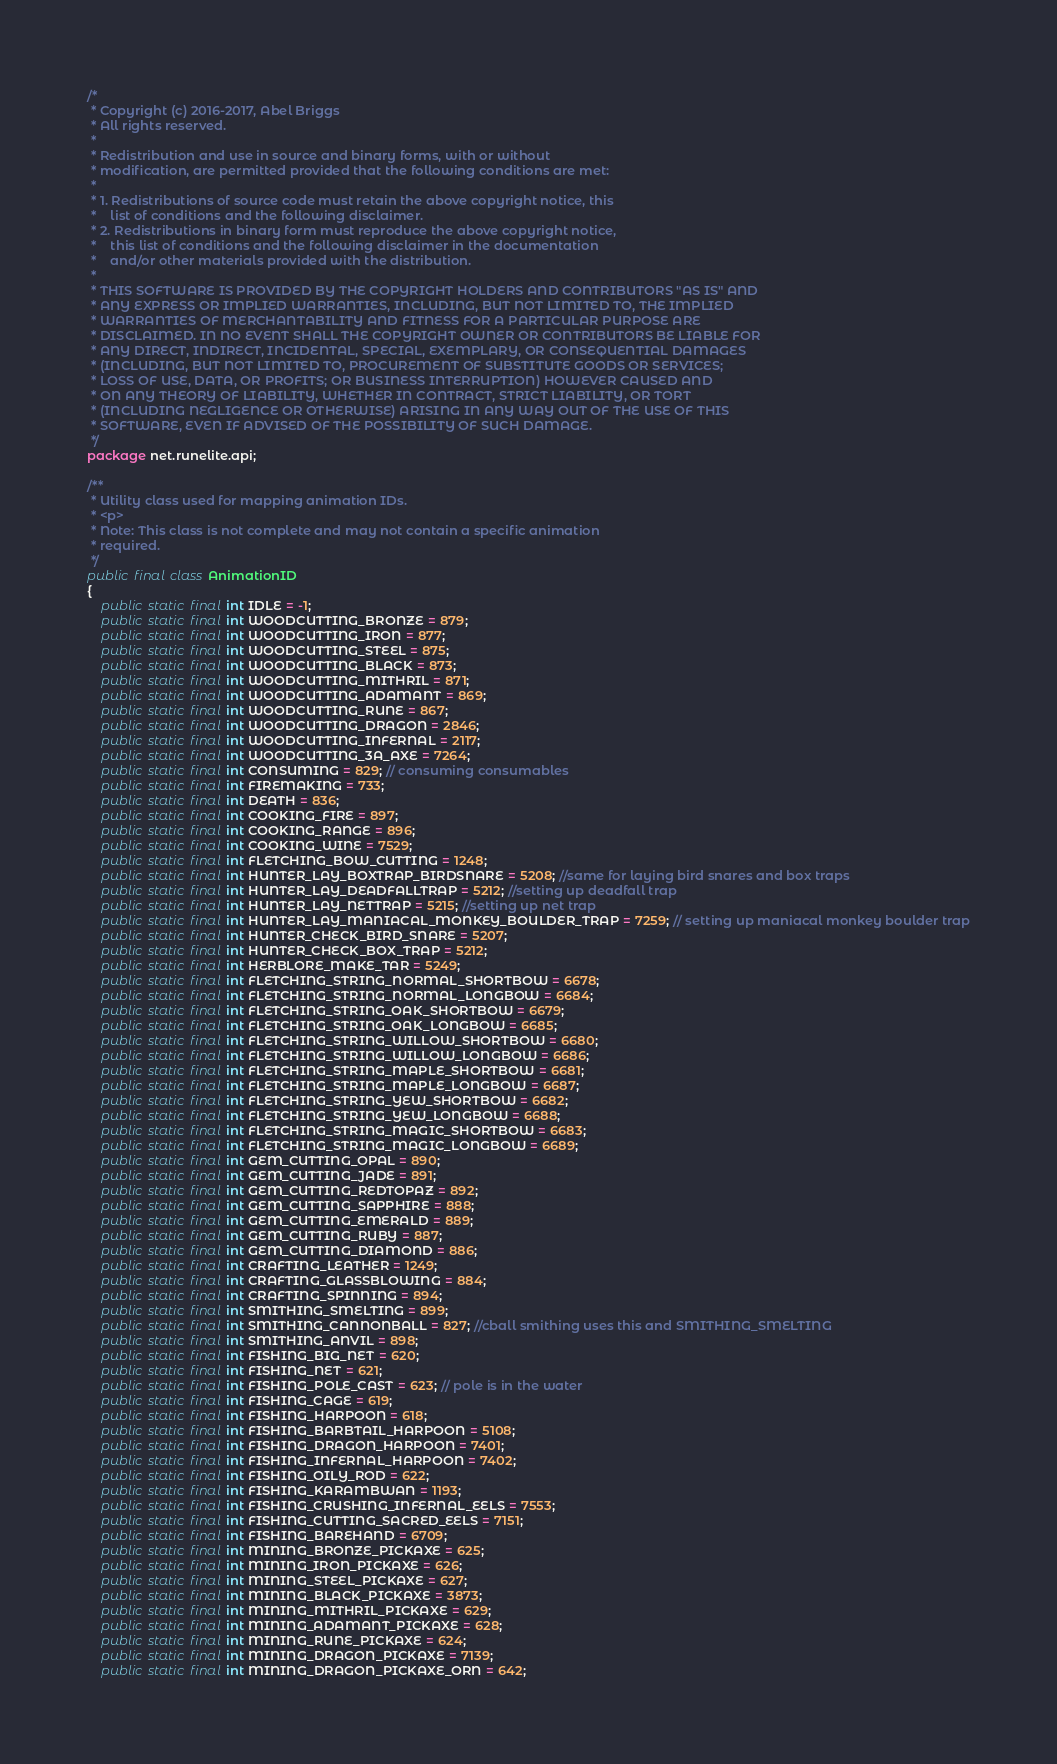<code> <loc_0><loc_0><loc_500><loc_500><_Java_>/*
 * Copyright (c) 2016-2017, Abel Briggs
 * All rights reserved.
 *
 * Redistribution and use in source and binary forms, with or without
 * modification, are permitted provided that the following conditions are met:
 *
 * 1. Redistributions of source code must retain the above copyright notice, this
 *    list of conditions and the following disclaimer.
 * 2. Redistributions in binary form must reproduce the above copyright notice,
 *    this list of conditions and the following disclaimer in the documentation
 *    and/or other materials provided with the distribution.
 *
 * THIS SOFTWARE IS PROVIDED BY THE COPYRIGHT HOLDERS AND CONTRIBUTORS "AS IS" AND
 * ANY EXPRESS OR IMPLIED WARRANTIES, INCLUDING, BUT NOT LIMITED TO, THE IMPLIED
 * WARRANTIES OF MERCHANTABILITY AND FITNESS FOR A PARTICULAR PURPOSE ARE
 * DISCLAIMED. IN NO EVENT SHALL THE COPYRIGHT OWNER OR CONTRIBUTORS BE LIABLE FOR
 * ANY DIRECT, INDIRECT, INCIDENTAL, SPECIAL, EXEMPLARY, OR CONSEQUENTIAL DAMAGES
 * (INCLUDING, BUT NOT LIMITED TO, PROCUREMENT OF SUBSTITUTE GOODS OR SERVICES;
 * LOSS OF USE, DATA, OR PROFITS; OR BUSINESS INTERRUPTION) HOWEVER CAUSED AND
 * ON ANY THEORY OF LIABILITY, WHETHER IN CONTRACT, STRICT LIABILITY, OR TORT
 * (INCLUDING NEGLIGENCE OR OTHERWISE) ARISING IN ANY WAY OUT OF THE USE OF THIS
 * SOFTWARE, EVEN IF ADVISED OF THE POSSIBILITY OF SUCH DAMAGE.
 */
package net.runelite.api;

/**
 * Utility class used for mapping animation IDs.
 * <p>
 * Note: This class is not complete and may not contain a specific animation
 * required.
 */
public final class AnimationID
{
	public static final int IDLE = -1;
	public static final int WOODCUTTING_BRONZE = 879;
	public static final int WOODCUTTING_IRON = 877;
	public static final int WOODCUTTING_STEEL = 875;
	public static final int WOODCUTTING_BLACK = 873;
	public static final int WOODCUTTING_MITHRIL = 871;
	public static final int WOODCUTTING_ADAMANT = 869;
	public static final int WOODCUTTING_RUNE = 867;
	public static final int WOODCUTTING_DRAGON = 2846;
	public static final int WOODCUTTING_INFERNAL = 2117;
	public static final int WOODCUTTING_3A_AXE = 7264;
	public static final int CONSUMING = 829; // consuming consumables
	public static final int FIREMAKING = 733;
	public static final int DEATH = 836;
	public static final int COOKING_FIRE = 897;
	public static final int COOKING_RANGE = 896;
	public static final int COOKING_WINE = 7529;
	public static final int FLETCHING_BOW_CUTTING = 1248;
	public static final int HUNTER_LAY_BOXTRAP_BIRDSNARE = 5208; //same for laying bird snares and box traps
	public static final int HUNTER_LAY_DEADFALLTRAP = 5212; //setting up deadfall trap
	public static final int HUNTER_LAY_NETTRAP = 5215; //setting up net trap
	public static final int HUNTER_LAY_MANIACAL_MONKEY_BOULDER_TRAP = 7259; // setting up maniacal monkey boulder trap
	public static final int HUNTER_CHECK_BIRD_SNARE = 5207;
	public static final int HUNTER_CHECK_BOX_TRAP = 5212;
	public static final int HERBLORE_MAKE_TAR = 5249;
	public static final int FLETCHING_STRING_NORMAL_SHORTBOW = 6678;
	public static final int FLETCHING_STRING_NORMAL_LONGBOW = 6684;
	public static final int FLETCHING_STRING_OAK_SHORTBOW = 6679;
	public static final int FLETCHING_STRING_OAK_LONGBOW = 6685;
	public static final int FLETCHING_STRING_WILLOW_SHORTBOW = 6680;
	public static final int FLETCHING_STRING_WILLOW_LONGBOW = 6686;
	public static final int FLETCHING_STRING_MAPLE_SHORTBOW = 6681;
	public static final int FLETCHING_STRING_MAPLE_LONGBOW = 6687;
	public static final int FLETCHING_STRING_YEW_SHORTBOW = 6682;
	public static final int FLETCHING_STRING_YEW_LONGBOW = 6688;
	public static final int FLETCHING_STRING_MAGIC_SHORTBOW = 6683;
	public static final int FLETCHING_STRING_MAGIC_LONGBOW = 6689;
	public static final int GEM_CUTTING_OPAL = 890;
	public static final int GEM_CUTTING_JADE = 891;
	public static final int GEM_CUTTING_REDTOPAZ = 892;
	public static final int GEM_CUTTING_SAPPHIRE = 888;
	public static final int GEM_CUTTING_EMERALD = 889;
	public static final int GEM_CUTTING_RUBY = 887;
	public static final int GEM_CUTTING_DIAMOND = 886;
	public static final int CRAFTING_LEATHER = 1249;
	public static final int CRAFTING_GLASSBLOWING = 884;
	public static final int CRAFTING_SPINNING = 894;
	public static final int SMITHING_SMELTING = 899;
	public static final int SMITHING_CANNONBALL = 827; //cball smithing uses this and SMITHING_SMELTING
	public static final int SMITHING_ANVIL = 898;
	public static final int FISHING_BIG_NET = 620;
	public static final int FISHING_NET = 621;
	public static final int FISHING_POLE_CAST = 623; // pole is in the water
	public static final int FISHING_CAGE = 619;
	public static final int FISHING_HARPOON = 618;
	public static final int FISHING_BARBTAIL_HARPOON = 5108;
	public static final int FISHING_DRAGON_HARPOON = 7401;
	public static final int FISHING_INFERNAL_HARPOON = 7402;
	public static final int FISHING_OILY_ROD = 622;
	public static final int FISHING_KARAMBWAN = 1193;
	public static final int FISHING_CRUSHING_INFERNAL_EELS = 7553;
	public static final int FISHING_CUTTING_SACRED_EELS = 7151;
	public static final int FISHING_BAREHAND = 6709;
	public static final int MINING_BRONZE_PICKAXE = 625;
	public static final int MINING_IRON_PICKAXE = 626;
	public static final int MINING_STEEL_PICKAXE = 627;
	public static final int MINING_BLACK_PICKAXE = 3873;
	public static final int MINING_MITHRIL_PICKAXE = 629;
	public static final int MINING_ADAMANT_PICKAXE = 628;
	public static final int MINING_RUNE_PICKAXE = 624;
	public static final int MINING_DRAGON_PICKAXE = 7139;
	public static final int MINING_DRAGON_PICKAXE_ORN = 642;</code> 